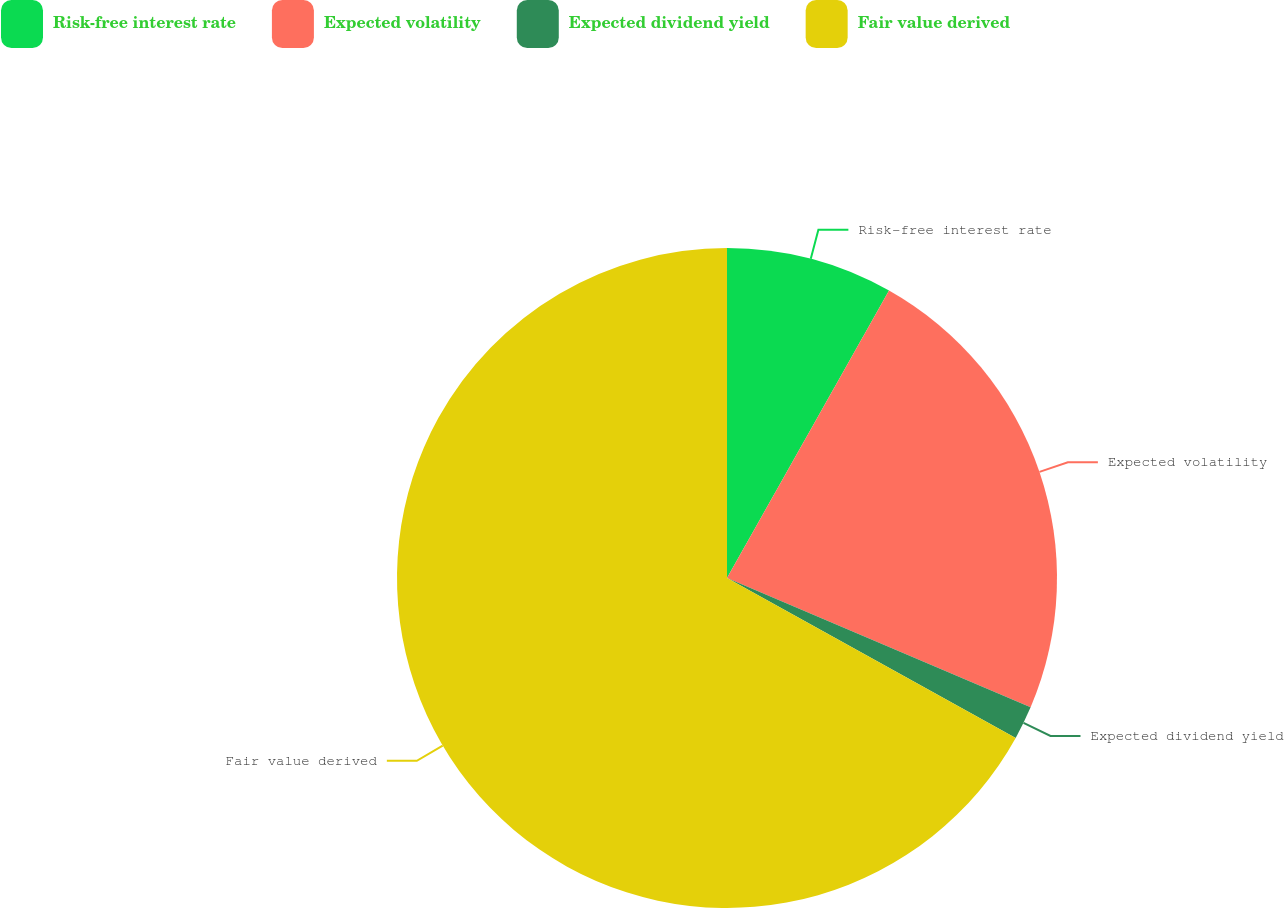Convert chart to OTSL. <chart><loc_0><loc_0><loc_500><loc_500><pie_chart><fcel>Risk-free interest rate<fcel>Expected volatility<fcel>Expected dividend yield<fcel>Fair value derived<nl><fcel>8.17%<fcel>23.24%<fcel>1.64%<fcel>66.95%<nl></chart> 